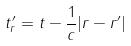Convert formula to latex. <formula><loc_0><loc_0><loc_500><loc_500>t _ { r } ^ { \prime } = t - \frac { 1 } { c } | r - r ^ { \prime } |</formula> 